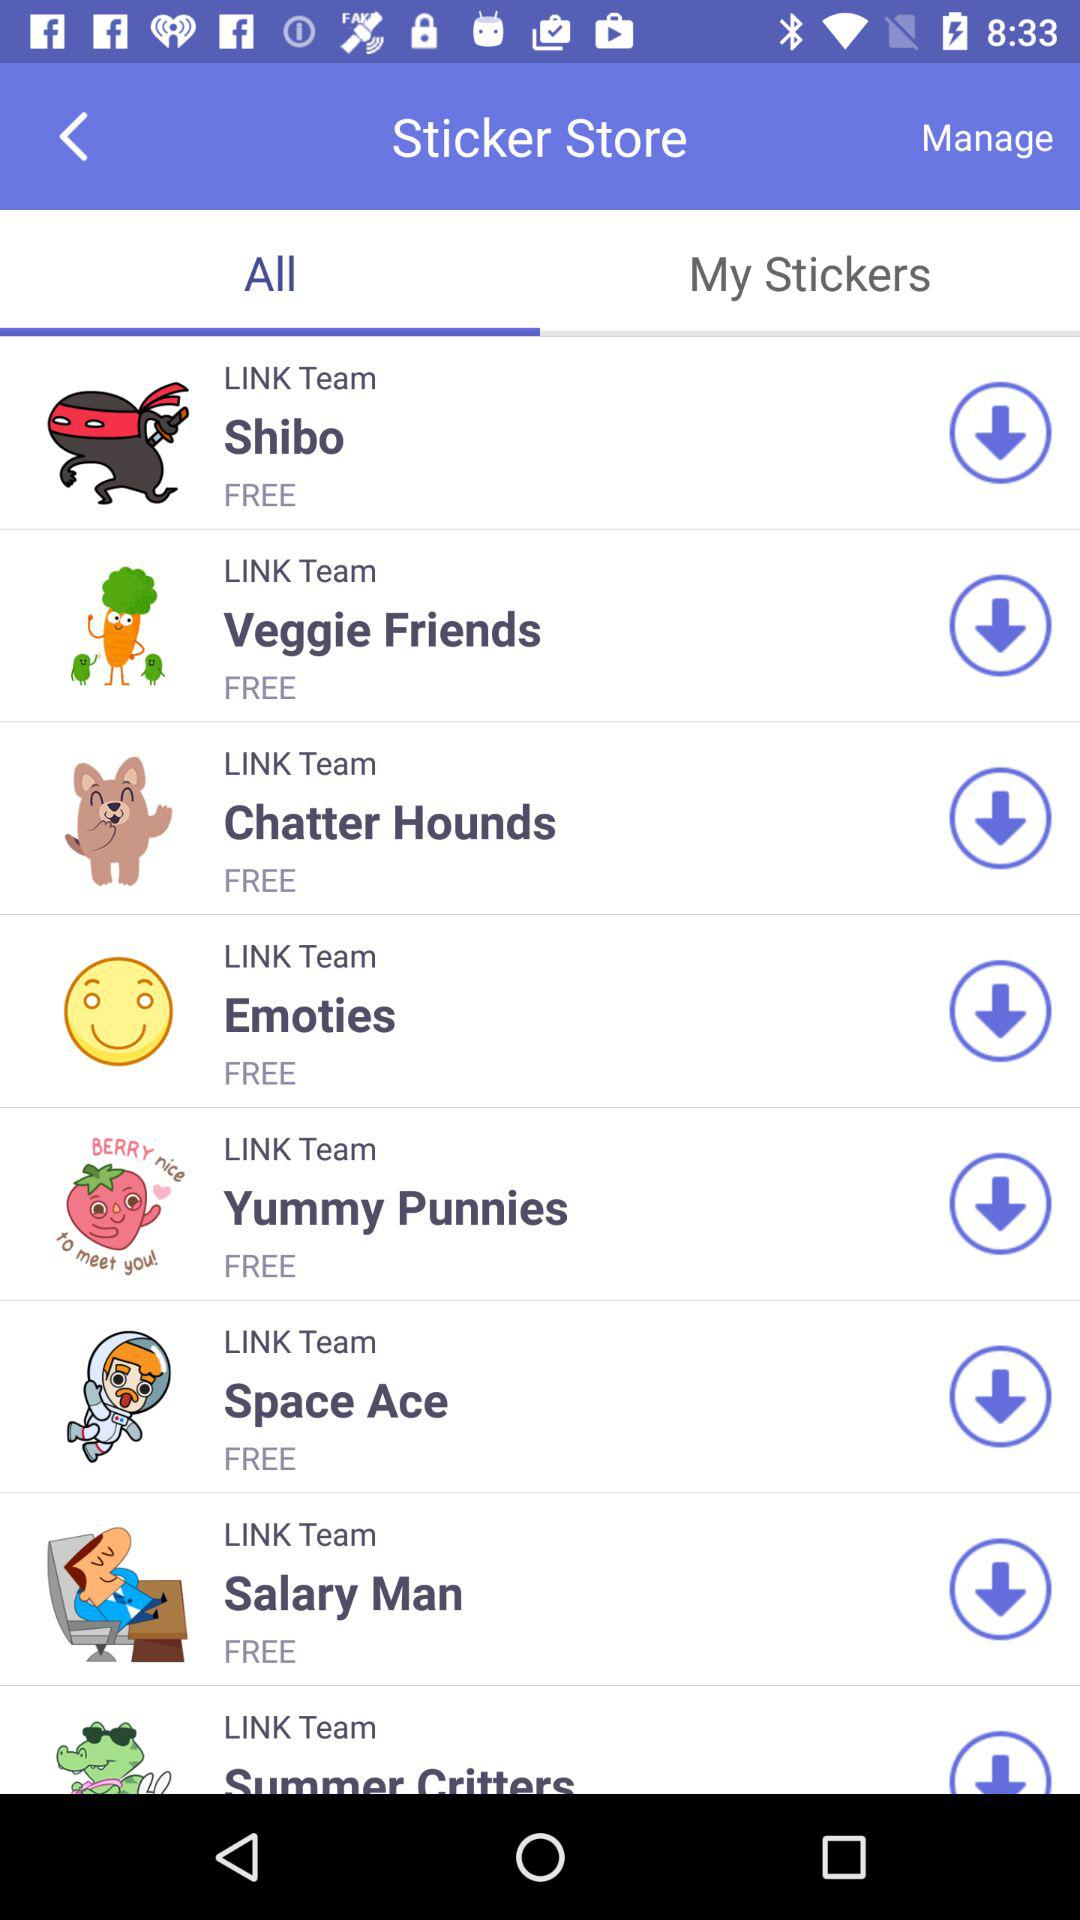How many items are in "My Stickers"?
When the provided information is insufficient, respond with <no answer>. <no answer> 